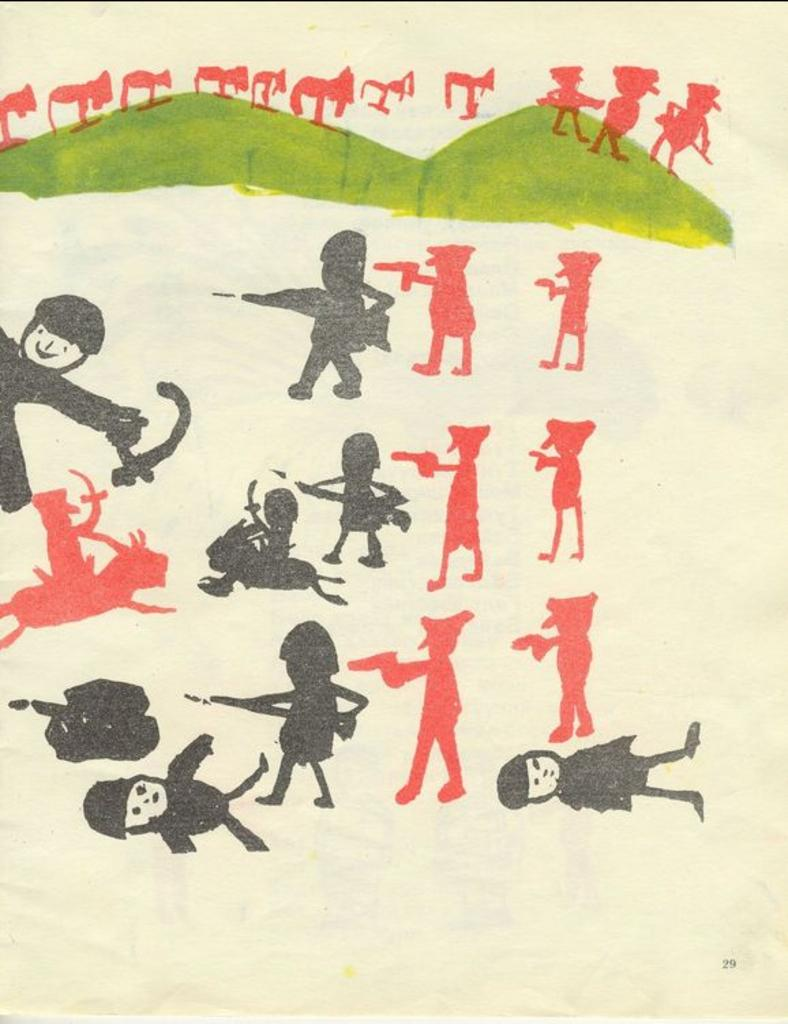What objects can be seen in the image? There are toys in the image. What type of natural formation is visible in the image? There are mountains in the image. What type of police car can be seen in the image? There is no police car present in the image; it only features toys and mountains. What type of view can be seen from the top of the mountain in the image? The image does not show a view from the top of the mountain, as it only depicts the mountain itself and toys. 